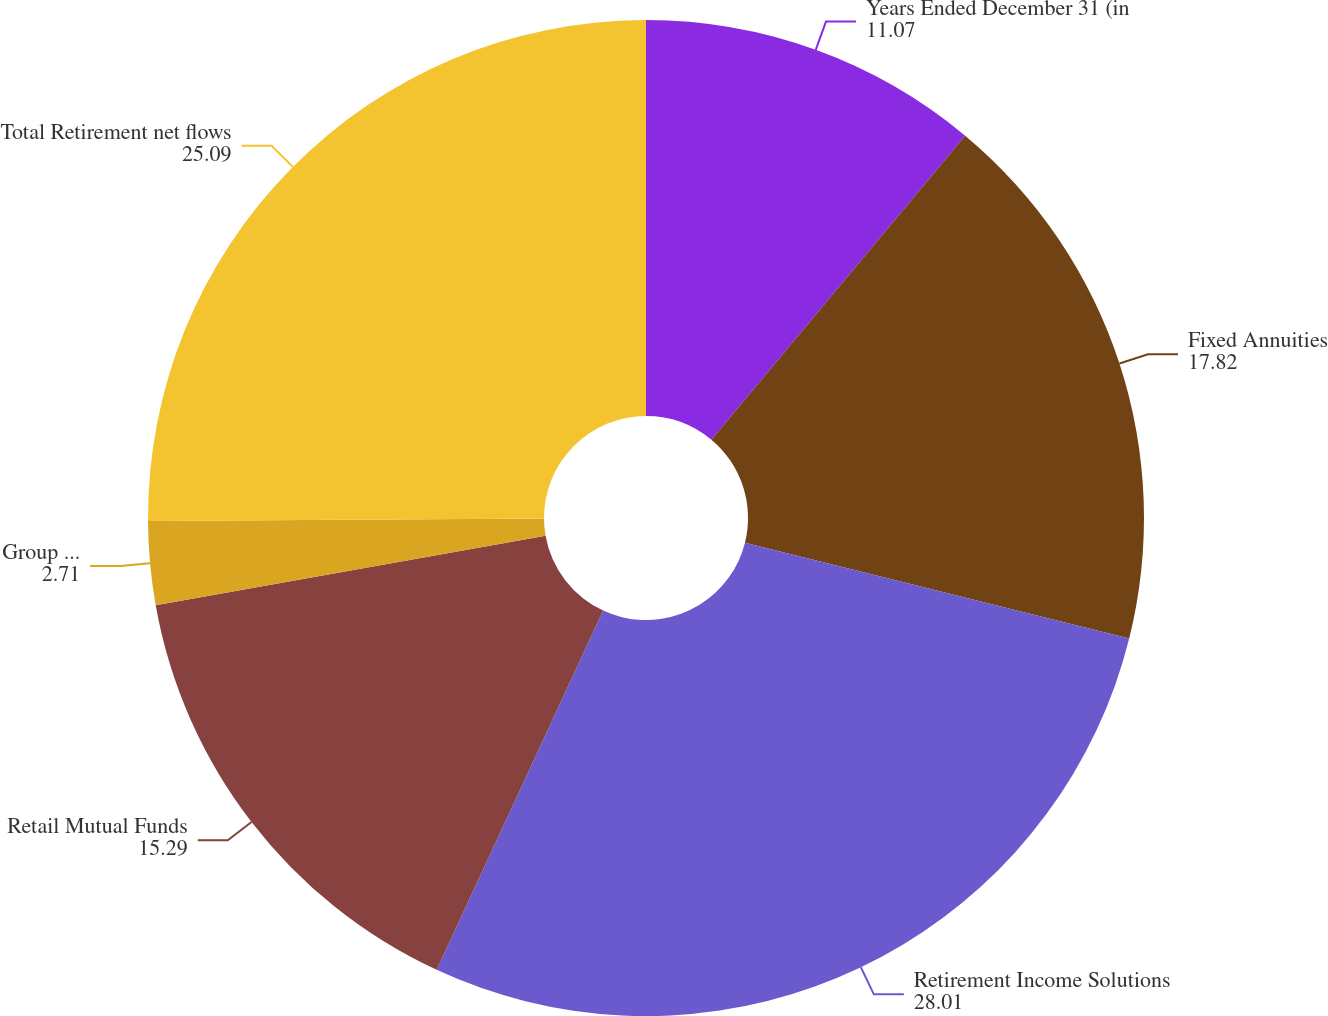Convert chart. <chart><loc_0><loc_0><loc_500><loc_500><pie_chart><fcel>Years Ended December 31 (in<fcel>Fixed Annuities<fcel>Retirement Income Solutions<fcel>Retail Mutual Funds<fcel>Group Retirement<fcel>Total Retirement net flows<nl><fcel>11.07%<fcel>17.82%<fcel>28.01%<fcel>15.29%<fcel>2.71%<fcel>25.09%<nl></chart> 